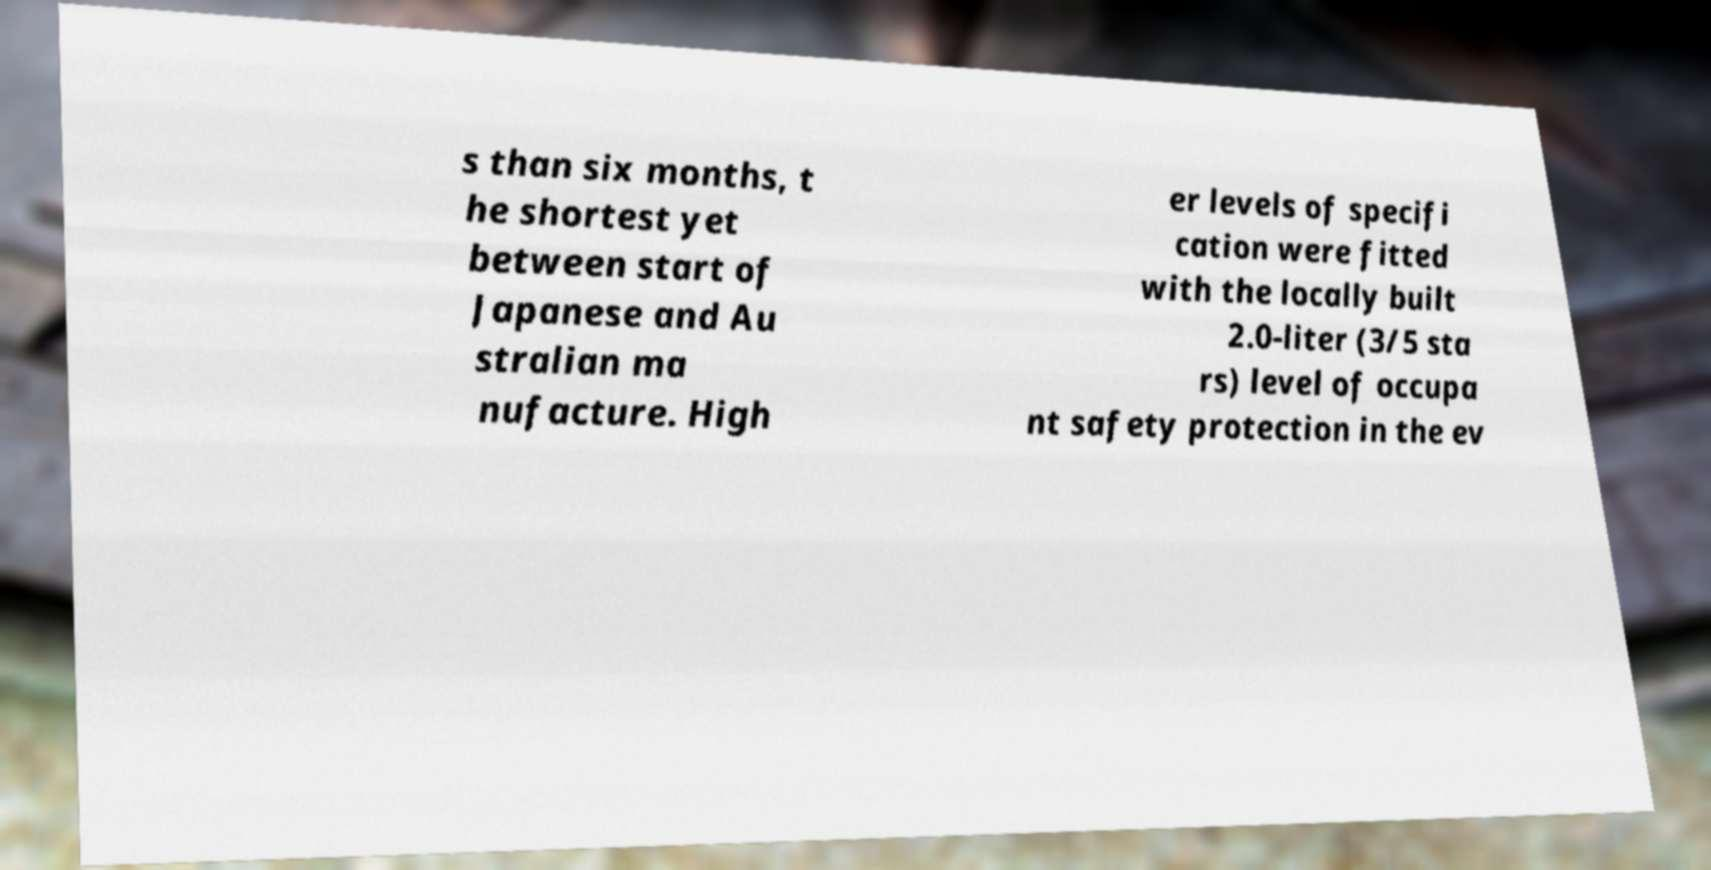Could you extract and type out the text from this image? s than six months, t he shortest yet between start of Japanese and Au stralian ma nufacture. High er levels of specifi cation were fitted with the locally built 2.0-liter (3/5 sta rs) level of occupa nt safety protection in the ev 